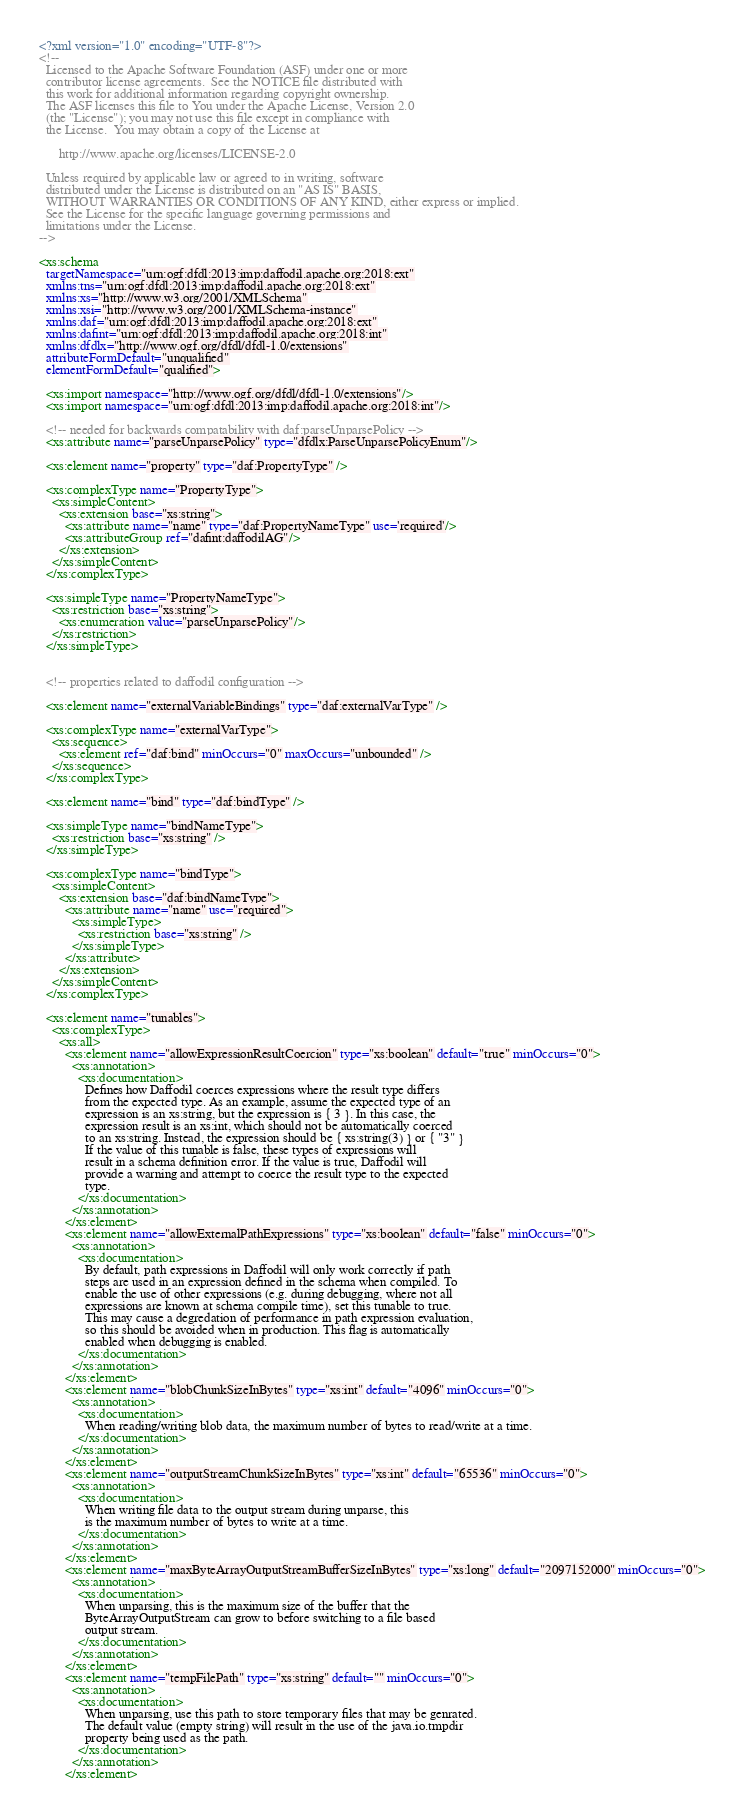<code> <loc_0><loc_0><loc_500><loc_500><_XML_><?xml version="1.0" encoding="UTF-8"?>
<!--
  Licensed to the Apache Software Foundation (ASF) under one or more
  contributor license agreements.  See the NOTICE file distributed with
  this work for additional information regarding copyright ownership.
  The ASF licenses this file to You under the Apache License, Version 2.0
  (the "License"); you may not use this file except in compliance with
  the License.  You may obtain a copy of the License at

      http://www.apache.org/licenses/LICENSE-2.0

  Unless required by applicable law or agreed to in writing, software
  distributed under the License is distributed on an "AS IS" BASIS,
  WITHOUT WARRANTIES OR CONDITIONS OF ANY KIND, either express or implied.
  See the License for the specific language governing permissions and
  limitations under the License.
-->

<xs:schema
  targetNamespace="urn:ogf:dfdl:2013:imp:daffodil.apache.org:2018:ext"
  xmlns:tns="urn:ogf:dfdl:2013:imp:daffodil.apache.org:2018:ext"
  xmlns:xs="http://www.w3.org/2001/XMLSchema"
  xmlns:xsi="http://www.w3.org/2001/XMLSchema-instance"
  xmlns:daf="urn:ogf:dfdl:2013:imp:daffodil.apache.org:2018:ext"
  xmlns:dafint="urn:ogf:dfdl:2013:imp:daffodil.apache.org:2018:int"
  xmlns:dfdlx="http://www.ogf.org/dfdl/dfdl-1.0/extensions"
  attributeFormDefault="unqualified"
  elementFormDefault="qualified">
  
  <xs:import namespace="http://www.ogf.org/dfdl/dfdl-1.0/extensions"/>
  <xs:import namespace="urn:ogf:dfdl:2013:imp:daffodil.apache.org:2018:int"/>

  <!-- needed for backwards compatability with daf:parseUnparsePolicy -->
  <xs:attribute name="parseUnparsePolicy" type="dfdlx:ParseUnparsePolicyEnum"/>

  <xs:element name="property" type="daf:PropertyType" />

  <xs:complexType name="PropertyType">
    <xs:simpleContent>
      <xs:extension base="xs:string">
        <xs:attribute name="name" type="daf:PropertyNameType" use='required'/>
        <xs:attributeGroup ref="dafint:daffodilAG"/>
      </xs:extension>
    </xs:simpleContent>
  </xs:complexType>

  <xs:simpleType name="PropertyNameType">
    <xs:restriction base="xs:string">
      <xs:enumeration value="parseUnparsePolicy"/>
    </xs:restriction>
  </xs:simpleType>


  <!-- properties related to daffodil configuration -->

  <xs:element name="externalVariableBindings" type="daf:externalVarType" />

  <xs:complexType name="externalVarType">
    <xs:sequence>
      <xs:element ref="daf:bind" minOccurs="0" maxOccurs="unbounded" />
    </xs:sequence>
  </xs:complexType>

  <xs:element name="bind" type="daf:bindType" />

  <xs:simpleType name="bindNameType">
    <xs:restriction base="xs:string" />
  </xs:simpleType>

  <xs:complexType name="bindType">
    <xs:simpleContent>
      <xs:extension base="daf:bindNameType">
        <xs:attribute name="name" use="required">
          <xs:simpleType>
            <xs:restriction base="xs:string" />
          </xs:simpleType>
        </xs:attribute>
      </xs:extension>
    </xs:simpleContent>
  </xs:complexType>

  <xs:element name="tunables">
    <xs:complexType>
      <xs:all>
        <xs:element name="allowExpressionResultCoercion" type="xs:boolean" default="true" minOccurs="0">
          <xs:annotation>
            <xs:documentation>
              Defines how Daffodil coerces expressions where the result type differs
              from the expected type. As an example, assume the expected type of an
              expression is an xs:string, but the expression is { 3 }. In this case, the
              expression result is an xs:int, which should not be automatically coerced
              to an xs:string. Instead, the expression should be { xs:string(3) } or { "3" }
              If the value of this tunable is false, these types of expressions will
              result in a schema definition error. If the value is true, Daffodil will
              provide a warning and attempt to coerce the result type to the expected
              type.
            </xs:documentation>
          </xs:annotation>
        </xs:element>
        <xs:element name="allowExternalPathExpressions" type="xs:boolean" default="false" minOccurs="0">
          <xs:annotation>
            <xs:documentation>
              By default, path expressions in Daffodil will only work correctly if path
              steps are used in an expression defined in the schema when compiled. To
              enable the use of other expressions (e.g. during debugging, where not all
              expressions are known at schema compile time), set this tunable to true.
              This may cause a degredation of performance in path expression evaluation,
              so this should be avoided when in production. This flag is automatically
              enabled when debugging is enabled.
            </xs:documentation>
          </xs:annotation>
        </xs:element>
        <xs:element name="blobChunkSizeInBytes" type="xs:int" default="4096" minOccurs="0">
          <xs:annotation>
            <xs:documentation>
              When reading/writing blob data, the maximum number of bytes to read/write at a time.
            </xs:documentation>
          </xs:annotation>
        </xs:element>
        <xs:element name="outputStreamChunkSizeInBytes" type="xs:int" default="65536" minOccurs="0">
          <xs:annotation>
            <xs:documentation>
              When writing file data to the output stream during unparse, this
              is the maximum number of bytes to write at a time.
            </xs:documentation>
          </xs:annotation>
        </xs:element>
        <xs:element name="maxByteArrayOutputStreamBufferSizeInBytes" type="xs:long" default="2097152000" minOccurs="0">
          <xs:annotation>
            <xs:documentation>
              When unparsing, this is the maximum size of the buffer that the
              ByteArrayOutputStream can grow to before switching to a file based
              output stream.
            </xs:documentation>
          </xs:annotation>
        </xs:element>
        <xs:element name="tempFilePath" type="xs:string" default="" minOccurs="0">
          <xs:annotation>
            <xs:documentation>
              When unparsing, use this path to store temporary files that may be genrated.
              The default value (empty string) will result in the use of the java.io.tmpdir
              property being used as the path.
            </xs:documentation>
          </xs:annotation>
        </xs:element></code> 